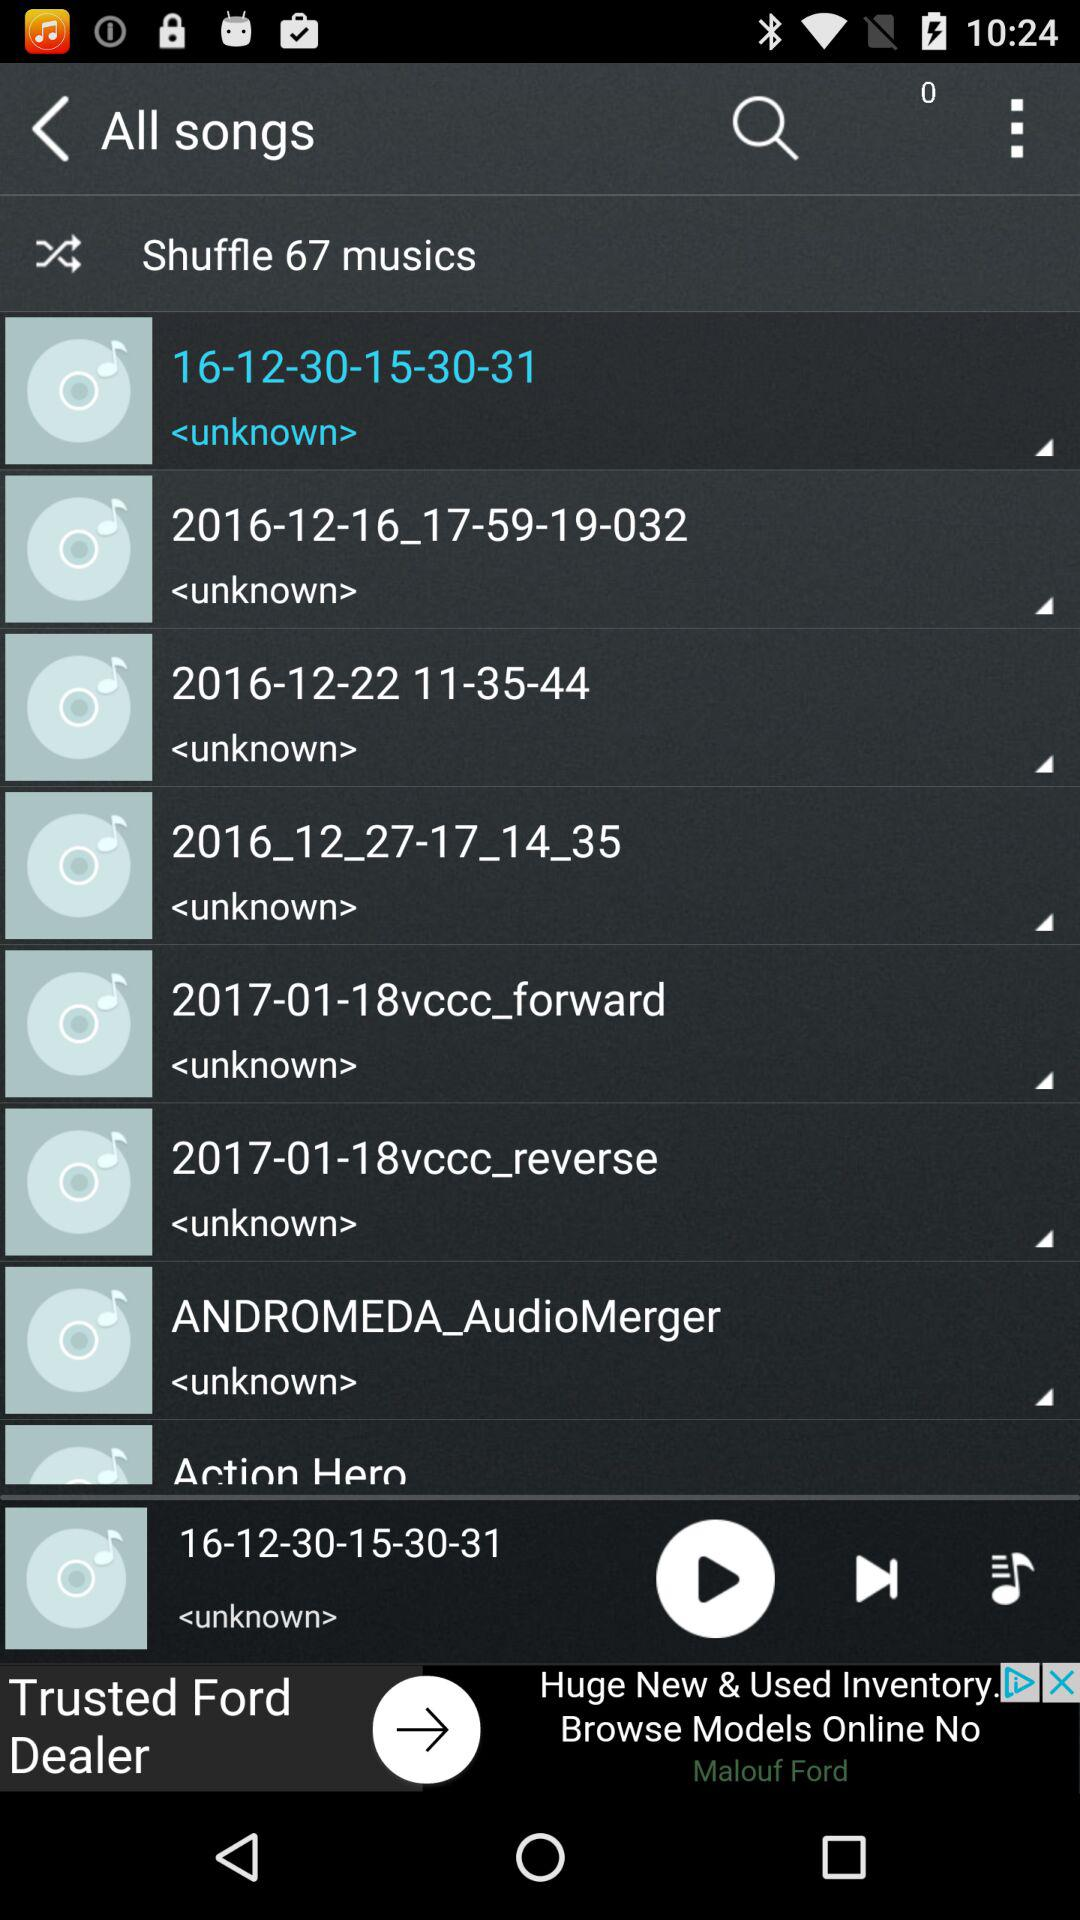How many songs are in the application? There are 67 songs in the application. 